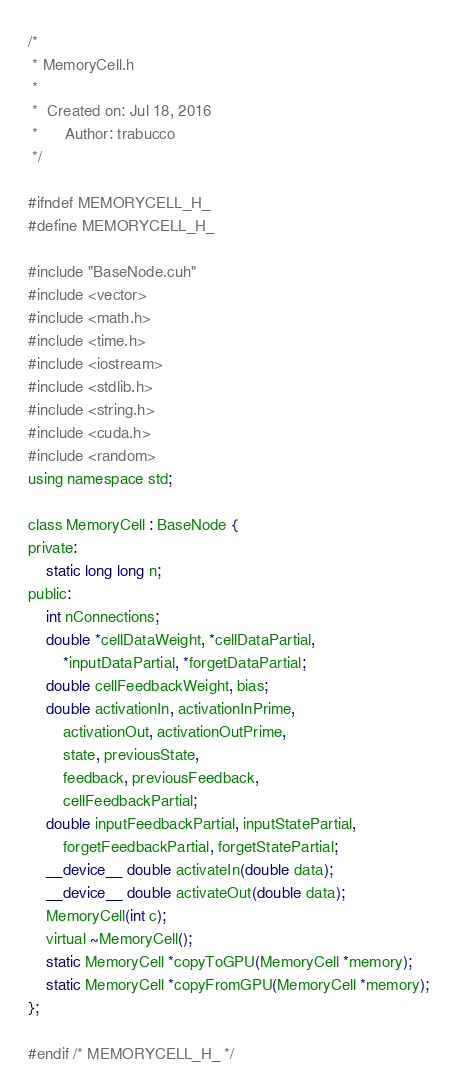<code> <loc_0><loc_0><loc_500><loc_500><_Cuda_>/*
 * MemoryCell.h
 *
 *  Created on: Jul 18, 2016
 *      Author: trabucco
 */

#ifndef MEMORYCELL_H_
#define MEMORYCELL_H_

#include "BaseNode.cuh"
#include <vector>
#include <math.h>
#include <time.h>
#include <iostream>
#include <stdlib.h>
#include <string.h>
#include <cuda.h>
#include <random>
using namespace std;

class MemoryCell : BaseNode {
private:
	static long long n;
public:
	int nConnections;
	double *cellDataWeight, *cellDataPartial,
		*inputDataPartial, *forgetDataPartial;
	double cellFeedbackWeight, bias;
	double activationIn, activationInPrime,
		activationOut, activationOutPrime,
		state, previousState,
		feedback, previousFeedback,
		cellFeedbackPartial;
	double inputFeedbackPartial, inputStatePartial,
		forgetFeedbackPartial, forgetStatePartial;
	__device__ double activateIn(double data);
	__device__ double activateOut(double data);
	MemoryCell(int c);
	virtual ~MemoryCell();
	static MemoryCell *copyToGPU(MemoryCell *memory);
	static MemoryCell *copyFromGPU(MemoryCell *memory);
};

#endif /* MEMORYCELL_H_ */
</code> 